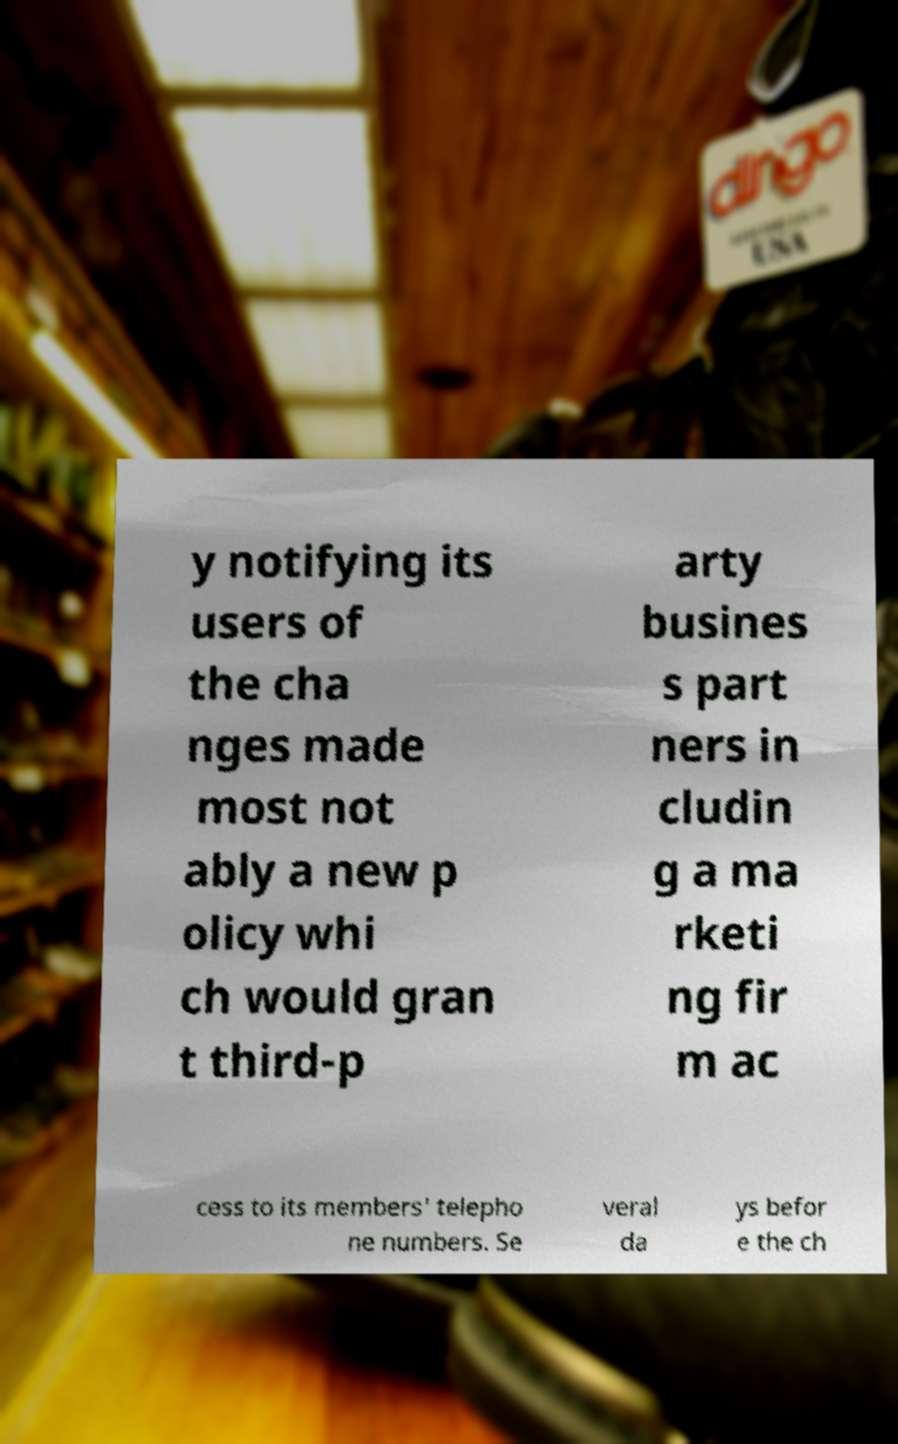Please identify and transcribe the text found in this image. y notifying its users of the cha nges made most not ably a new p olicy whi ch would gran t third-p arty busines s part ners in cludin g a ma rketi ng fir m ac cess to its members' telepho ne numbers. Se veral da ys befor e the ch 